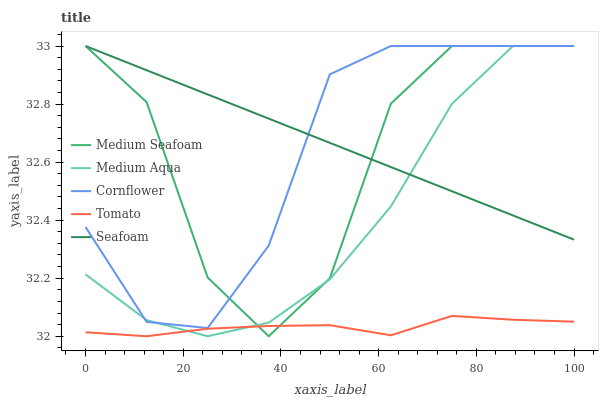Does Cornflower have the minimum area under the curve?
Answer yes or no. No. Does Cornflower have the maximum area under the curve?
Answer yes or no. No. Is Cornflower the smoothest?
Answer yes or no. No. Is Cornflower the roughest?
Answer yes or no. No. Does Cornflower have the lowest value?
Answer yes or no. No. Is Tomato less than Seafoam?
Answer yes or no. Yes. Is Seafoam greater than Tomato?
Answer yes or no. Yes. Does Tomato intersect Seafoam?
Answer yes or no. No. 